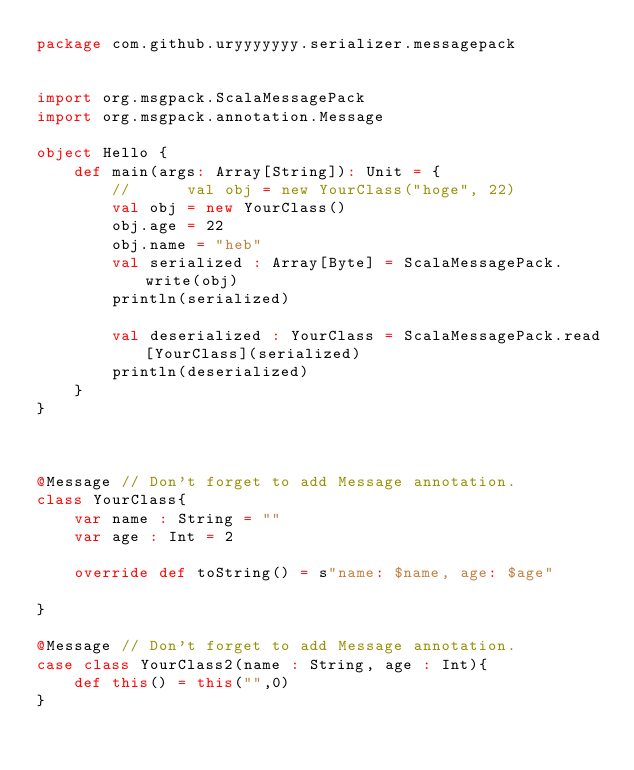<code> <loc_0><loc_0><loc_500><loc_500><_Scala_>package com.github.uryyyyyyy.serializer.messagepack


import org.msgpack.ScalaMessagePack
import org.msgpack.annotation.Message

object Hello {
	def main(args: Array[String]): Unit = {
		//		val obj = new YourClass("hoge", 22)
		val obj = new YourClass()
		obj.age = 22
		obj.name = "heb"
		val serialized : Array[Byte] = ScalaMessagePack.write(obj)
		println(serialized)

		val deserialized : YourClass = ScalaMessagePack.read[YourClass](serialized)
		println(deserialized)
	}
}



@Message // Don't forget to add Message annotation.
class YourClass{
	var name : String = ""
	var age : Int = 2

	override def toString() = s"name: $name, age: $age"

}

@Message // Don't forget to add Message annotation.
case class YourClass2(name : String, age : Int){
	def this() = this("",0)
}</code> 